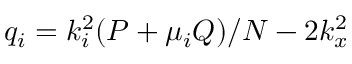Convert formula to latex. <formula><loc_0><loc_0><loc_500><loc_500>q _ { i } = k _ { i } ^ { 2 } ( P + \mu _ { i } Q ) / N - 2 k _ { x } ^ { 2 }</formula> 